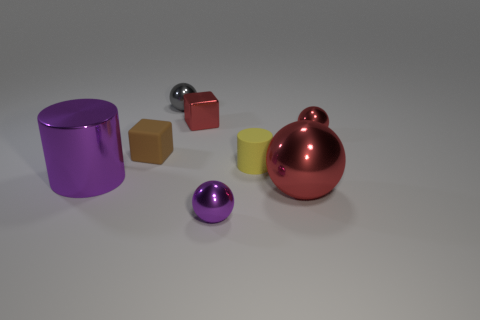Is the number of small spheres that are left of the tiny purple metallic object greater than the number of small cyan blocks?
Offer a terse response. Yes. There is a metallic thing that is to the left of the purple ball and in front of the yellow matte cylinder; what size is it?
Give a very brief answer. Large. There is a metal object that is both on the left side of the metallic block and in front of the gray sphere; what is its shape?
Make the answer very short. Cylinder. Are there any red objects that are left of the small thing in front of the large purple object that is in front of the small red metal sphere?
Offer a terse response. Yes. What number of objects are either purple objects in front of the metallic cylinder or balls that are in front of the large red metal ball?
Keep it short and to the point. 1. Does the red object that is behind the small red metal ball have the same material as the small cylinder?
Your answer should be very brief. No. What material is the tiny object that is both in front of the tiny rubber block and behind the purple metal sphere?
Your answer should be very brief. Rubber. There is a matte object that is right of the tiny gray object to the left of the small red cube; what is its color?
Offer a very short reply. Yellow. There is a red object that is the same shape as the tiny brown rubber object; what is its material?
Your answer should be compact. Metal. What is the color of the large metallic thing behind the red metal sphere that is on the left side of the small metallic thing that is on the right side of the large red metal thing?
Provide a short and direct response. Purple. 